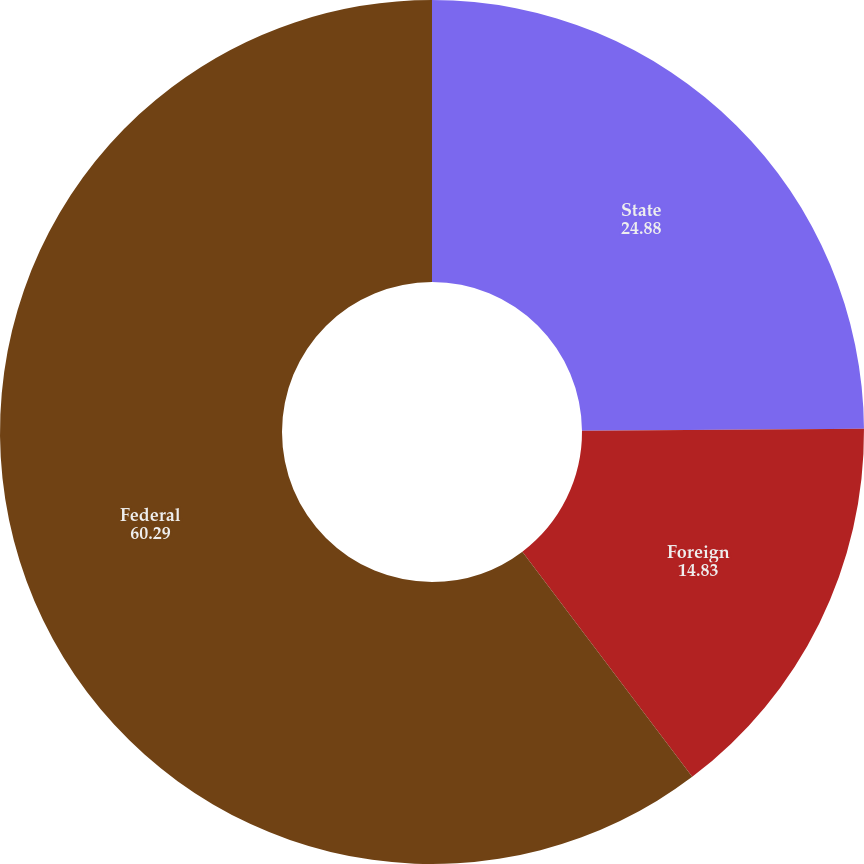<chart> <loc_0><loc_0><loc_500><loc_500><pie_chart><fcel>State<fcel>Foreign<fcel>Federal<nl><fcel>24.88%<fcel>14.83%<fcel>60.29%<nl></chart> 